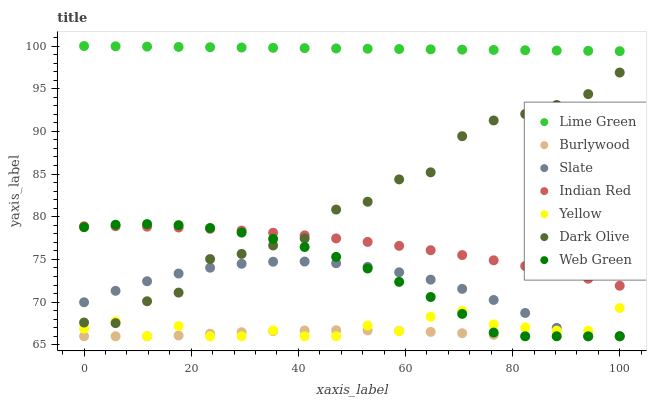Does Burlywood have the minimum area under the curve?
Answer yes or no. Yes. Does Lime Green have the maximum area under the curve?
Answer yes or no. Yes. Does Slate have the minimum area under the curve?
Answer yes or no. No. Does Slate have the maximum area under the curve?
Answer yes or no. No. Is Lime Green the smoothest?
Answer yes or no. Yes. Is Dark Olive the roughest?
Answer yes or no. Yes. Is Slate the smoothest?
Answer yes or no. No. Is Slate the roughest?
Answer yes or no. No. Does Burlywood have the lowest value?
Answer yes or no. Yes. Does Dark Olive have the lowest value?
Answer yes or no. No. Does Lime Green have the highest value?
Answer yes or no. Yes. Does Slate have the highest value?
Answer yes or no. No. Is Burlywood less than Indian Red?
Answer yes or no. Yes. Is Lime Green greater than Web Green?
Answer yes or no. Yes. Does Burlywood intersect Slate?
Answer yes or no. Yes. Is Burlywood less than Slate?
Answer yes or no. No. Is Burlywood greater than Slate?
Answer yes or no. No. Does Burlywood intersect Indian Red?
Answer yes or no. No. 